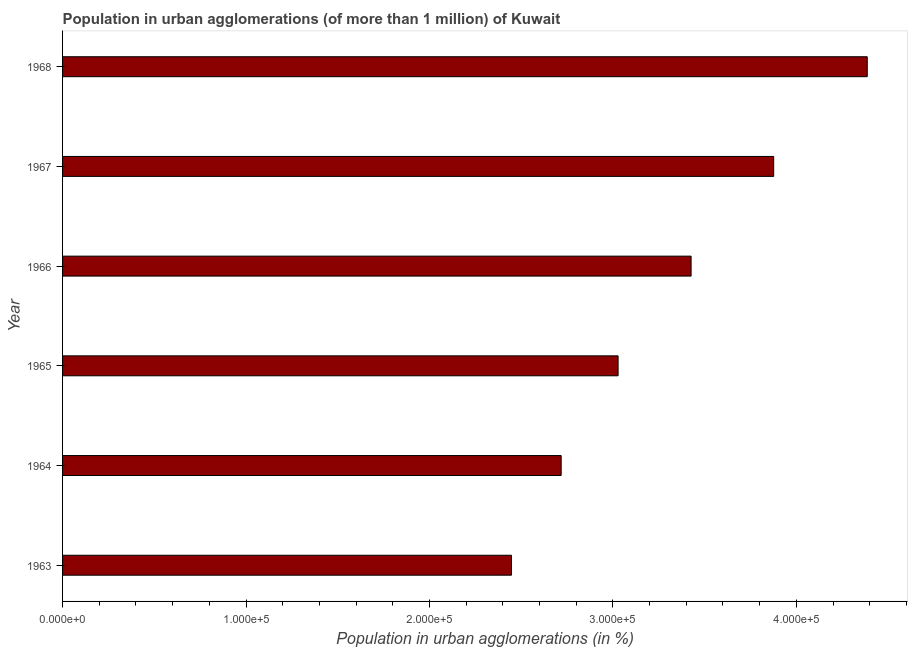Does the graph contain any zero values?
Offer a very short reply. No. Does the graph contain grids?
Ensure brevity in your answer.  No. What is the title of the graph?
Your response must be concise. Population in urban agglomerations (of more than 1 million) of Kuwait. What is the label or title of the X-axis?
Give a very brief answer. Population in urban agglomerations (in %). What is the label or title of the Y-axis?
Give a very brief answer. Year. What is the population in urban agglomerations in 1966?
Provide a short and direct response. 3.43e+05. Across all years, what is the maximum population in urban agglomerations?
Provide a succinct answer. 4.39e+05. Across all years, what is the minimum population in urban agglomerations?
Your answer should be very brief. 2.45e+05. In which year was the population in urban agglomerations maximum?
Make the answer very short. 1968. In which year was the population in urban agglomerations minimum?
Keep it short and to the point. 1963. What is the sum of the population in urban agglomerations?
Ensure brevity in your answer.  1.99e+06. What is the difference between the population in urban agglomerations in 1965 and 1968?
Offer a very short reply. -1.36e+05. What is the average population in urban agglomerations per year?
Your answer should be very brief. 3.31e+05. What is the median population in urban agglomerations?
Your answer should be very brief. 3.23e+05. In how many years, is the population in urban agglomerations greater than 40000 %?
Provide a short and direct response. 6. Do a majority of the years between 1965 and 1968 (inclusive) have population in urban agglomerations greater than 300000 %?
Make the answer very short. Yes. What is the ratio of the population in urban agglomerations in 1964 to that in 1967?
Ensure brevity in your answer.  0.7. What is the difference between the highest and the second highest population in urban agglomerations?
Offer a terse response. 5.10e+04. Is the sum of the population in urban agglomerations in 1965 and 1968 greater than the maximum population in urban agglomerations across all years?
Make the answer very short. Yes. What is the difference between the highest and the lowest population in urban agglomerations?
Ensure brevity in your answer.  1.94e+05. How many bars are there?
Make the answer very short. 6. Are all the bars in the graph horizontal?
Your response must be concise. Yes. What is the difference between two consecutive major ticks on the X-axis?
Keep it short and to the point. 1.00e+05. What is the Population in urban agglomerations (in %) of 1963?
Give a very brief answer. 2.45e+05. What is the Population in urban agglomerations (in %) in 1964?
Your answer should be very brief. 2.72e+05. What is the Population in urban agglomerations (in %) in 1965?
Your answer should be compact. 3.03e+05. What is the Population in urban agglomerations (in %) in 1966?
Give a very brief answer. 3.43e+05. What is the Population in urban agglomerations (in %) of 1967?
Your response must be concise. 3.88e+05. What is the Population in urban agglomerations (in %) of 1968?
Provide a short and direct response. 4.39e+05. What is the difference between the Population in urban agglomerations (in %) in 1963 and 1964?
Make the answer very short. -2.71e+04. What is the difference between the Population in urban agglomerations (in %) in 1963 and 1965?
Your response must be concise. -5.81e+04. What is the difference between the Population in urban agglomerations (in %) in 1963 and 1966?
Keep it short and to the point. -9.79e+04. What is the difference between the Population in urban agglomerations (in %) in 1963 and 1967?
Your answer should be compact. -1.43e+05. What is the difference between the Population in urban agglomerations (in %) in 1963 and 1968?
Make the answer very short. -1.94e+05. What is the difference between the Population in urban agglomerations (in %) in 1964 and 1965?
Offer a terse response. -3.10e+04. What is the difference between the Population in urban agglomerations (in %) in 1964 and 1966?
Make the answer very short. -7.08e+04. What is the difference between the Population in urban agglomerations (in %) in 1964 and 1967?
Ensure brevity in your answer.  -1.16e+05. What is the difference between the Population in urban agglomerations (in %) in 1964 and 1968?
Ensure brevity in your answer.  -1.67e+05. What is the difference between the Population in urban agglomerations (in %) in 1965 and 1966?
Your answer should be compact. -3.98e+04. What is the difference between the Population in urban agglomerations (in %) in 1965 and 1967?
Provide a short and direct response. -8.48e+04. What is the difference between the Population in urban agglomerations (in %) in 1965 and 1968?
Your answer should be compact. -1.36e+05. What is the difference between the Population in urban agglomerations (in %) in 1966 and 1967?
Give a very brief answer. -4.50e+04. What is the difference between the Population in urban agglomerations (in %) in 1966 and 1968?
Give a very brief answer. -9.60e+04. What is the difference between the Population in urban agglomerations (in %) in 1967 and 1968?
Offer a very short reply. -5.10e+04. What is the ratio of the Population in urban agglomerations (in %) in 1963 to that in 1964?
Ensure brevity in your answer.  0.9. What is the ratio of the Population in urban agglomerations (in %) in 1963 to that in 1965?
Your answer should be compact. 0.81. What is the ratio of the Population in urban agglomerations (in %) in 1963 to that in 1966?
Offer a terse response. 0.71. What is the ratio of the Population in urban agglomerations (in %) in 1963 to that in 1967?
Ensure brevity in your answer.  0.63. What is the ratio of the Population in urban agglomerations (in %) in 1963 to that in 1968?
Your answer should be very brief. 0.56. What is the ratio of the Population in urban agglomerations (in %) in 1964 to that in 1965?
Provide a succinct answer. 0.9. What is the ratio of the Population in urban agglomerations (in %) in 1964 to that in 1966?
Keep it short and to the point. 0.79. What is the ratio of the Population in urban agglomerations (in %) in 1964 to that in 1967?
Keep it short and to the point. 0.7. What is the ratio of the Population in urban agglomerations (in %) in 1964 to that in 1968?
Offer a very short reply. 0.62. What is the ratio of the Population in urban agglomerations (in %) in 1965 to that in 1966?
Your answer should be very brief. 0.88. What is the ratio of the Population in urban agglomerations (in %) in 1965 to that in 1967?
Provide a short and direct response. 0.78. What is the ratio of the Population in urban agglomerations (in %) in 1965 to that in 1968?
Make the answer very short. 0.69. What is the ratio of the Population in urban agglomerations (in %) in 1966 to that in 1967?
Provide a succinct answer. 0.88. What is the ratio of the Population in urban agglomerations (in %) in 1966 to that in 1968?
Make the answer very short. 0.78. What is the ratio of the Population in urban agglomerations (in %) in 1967 to that in 1968?
Provide a succinct answer. 0.88. 